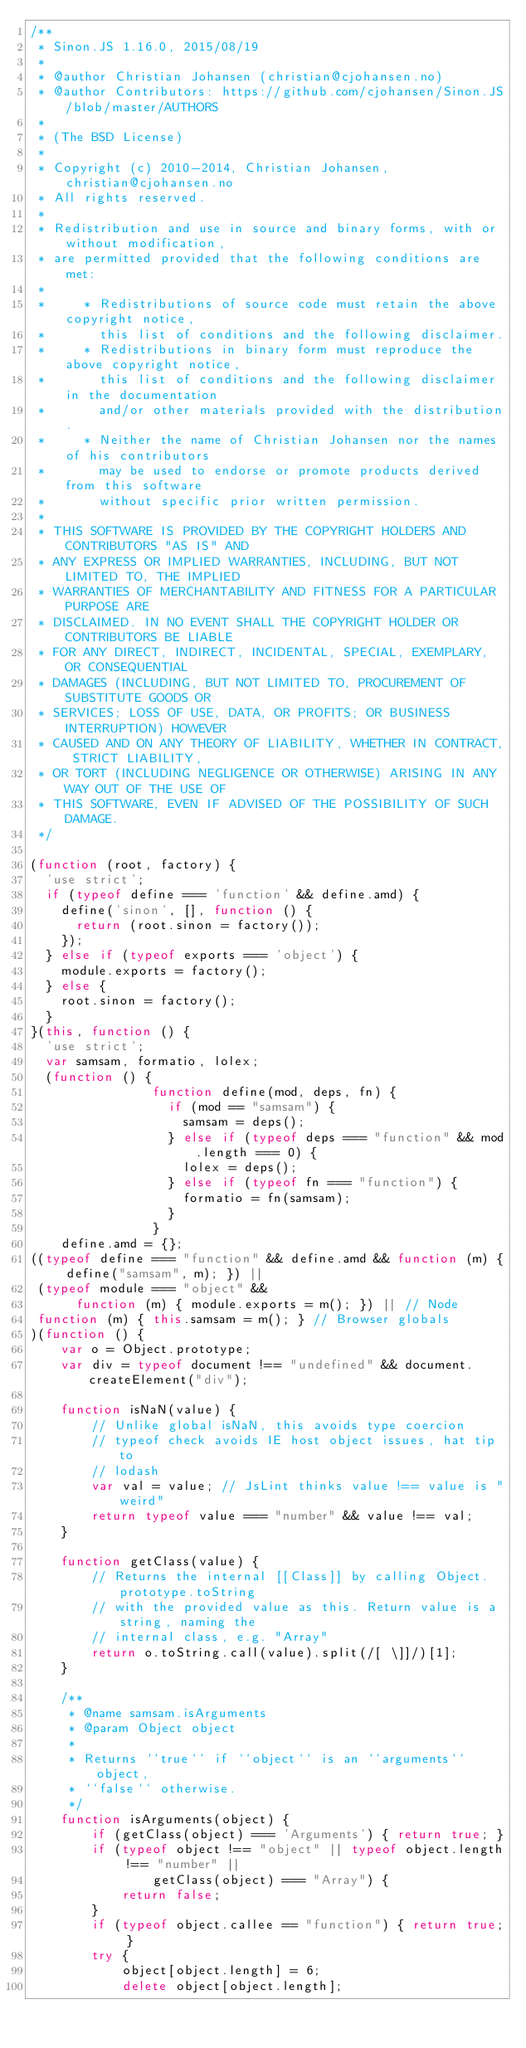<code> <loc_0><loc_0><loc_500><loc_500><_JavaScript_>/**
 * Sinon.JS 1.16.0, 2015/08/19
 *
 * @author Christian Johansen (christian@cjohansen.no)
 * @author Contributors: https://github.com/cjohansen/Sinon.JS/blob/master/AUTHORS
 *
 * (The BSD License)
 * 
 * Copyright (c) 2010-2014, Christian Johansen, christian@cjohansen.no
 * All rights reserved.
 * 
 * Redistribution and use in source and binary forms, with or without modification,
 * are permitted provided that the following conditions are met:
 * 
 *     * Redistributions of source code must retain the above copyright notice,
 *       this list of conditions and the following disclaimer.
 *     * Redistributions in binary form must reproduce the above copyright notice,
 *       this list of conditions and the following disclaimer in the documentation
 *       and/or other materials provided with the distribution.
 *     * Neither the name of Christian Johansen nor the names of his contributors
 *       may be used to endorse or promote products derived from this software
 *       without specific prior written permission.
 * 
 * THIS SOFTWARE IS PROVIDED BY THE COPYRIGHT HOLDERS AND CONTRIBUTORS "AS IS" AND
 * ANY EXPRESS OR IMPLIED WARRANTIES, INCLUDING, BUT NOT LIMITED TO, THE IMPLIED
 * WARRANTIES OF MERCHANTABILITY AND FITNESS FOR A PARTICULAR PURPOSE ARE
 * DISCLAIMED. IN NO EVENT SHALL THE COPYRIGHT HOLDER OR CONTRIBUTORS BE LIABLE
 * FOR ANY DIRECT, INDIRECT, INCIDENTAL, SPECIAL, EXEMPLARY, OR CONSEQUENTIAL
 * DAMAGES (INCLUDING, BUT NOT LIMITED TO, PROCUREMENT OF SUBSTITUTE GOODS OR
 * SERVICES; LOSS OF USE, DATA, OR PROFITS; OR BUSINESS INTERRUPTION) HOWEVER
 * CAUSED AND ON ANY THEORY OF LIABILITY, WHETHER IN CONTRACT, STRICT LIABILITY,
 * OR TORT (INCLUDING NEGLIGENCE OR OTHERWISE) ARISING IN ANY WAY OUT OF THE USE OF
 * THIS SOFTWARE, EVEN IF ADVISED OF THE POSSIBILITY OF SUCH DAMAGE.
 */

(function (root, factory) {
  'use strict';
  if (typeof define === 'function' && define.amd) {
    define('sinon', [], function () {
      return (root.sinon = factory());
    });
  } else if (typeof exports === 'object') {
    module.exports = factory();
  } else {
    root.sinon = factory();
  }
}(this, function () {
  'use strict';
  var samsam, formatio, lolex;
  (function () {
                function define(mod, deps, fn) {
                  if (mod == "samsam") {
                    samsam = deps();
                  } else if (typeof deps === "function" && mod.length === 0) {
                    lolex = deps();
                  } else if (typeof fn === "function") {
                    formatio = fn(samsam);
                  }
                }
    define.amd = {};
((typeof define === "function" && define.amd && function (m) { define("samsam", m); }) ||
 (typeof module === "object" &&
      function (m) { module.exports = m(); }) || // Node
 function (m) { this.samsam = m(); } // Browser globals
)(function () {
    var o = Object.prototype;
    var div = typeof document !== "undefined" && document.createElement("div");

    function isNaN(value) {
        // Unlike global isNaN, this avoids type coercion
        // typeof check avoids IE host object issues, hat tip to
        // lodash
        var val = value; // JsLint thinks value !== value is "weird"
        return typeof value === "number" && value !== val;
    }

    function getClass(value) {
        // Returns the internal [[Class]] by calling Object.prototype.toString
        // with the provided value as this. Return value is a string, naming the
        // internal class, e.g. "Array"
        return o.toString.call(value).split(/[ \]]/)[1];
    }

    /**
     * @name samsam.isArguments
     * @param Object object
     *
     * Returns ``true`` if ``object`` is an ``arguments`` object,
     * ``false`` otherwise.
     */
    function isArguments(object) {
        if (getClass(object) === 'Arguments') { return true; }
        if (typeof object !== "object" || typeof object.length !== "number" ||
                getClass(object) === "Array") {
            return false;
        }
        if (typeof object.callee == "function") { return true; }
        try {
            object[object.length] = 6;
            delete object[object.length];</code> 